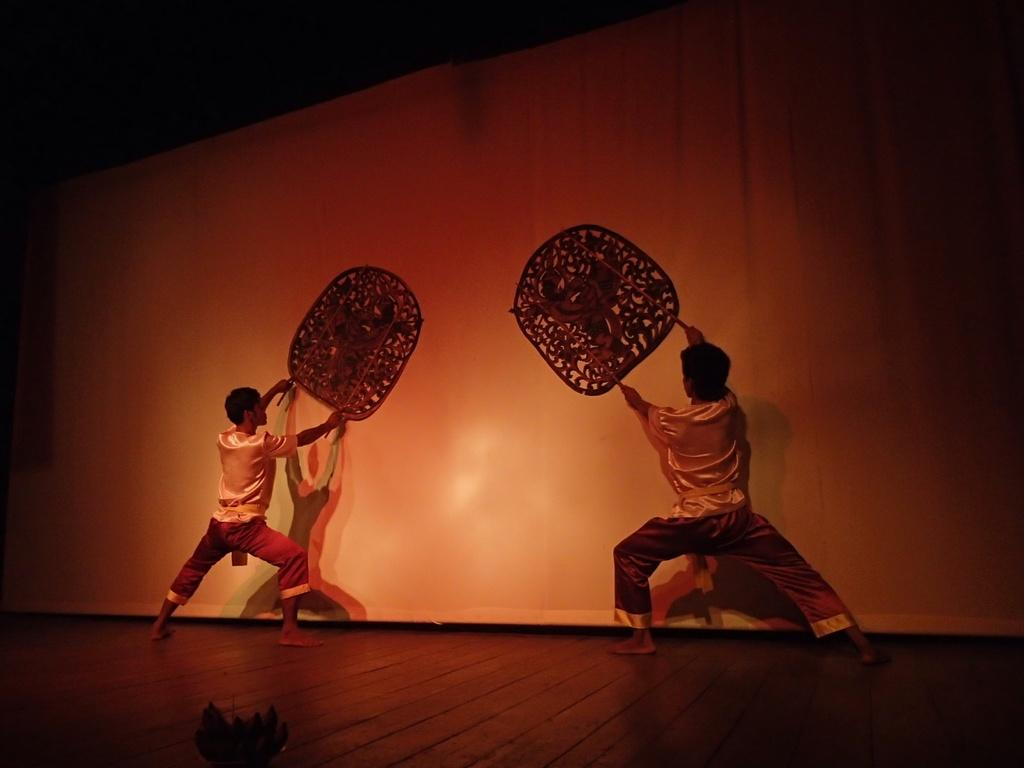How many people are in the image? There are two boys in the image. What are the boys doing in the image? The boys are performing an activity. Where is the activity taking place? The activity is taking place on a stage. Is there any smoke coming from the stage during the boys' performance? There is no mention of smoke in the image, so it cannot be determined if there is any smoke present. 